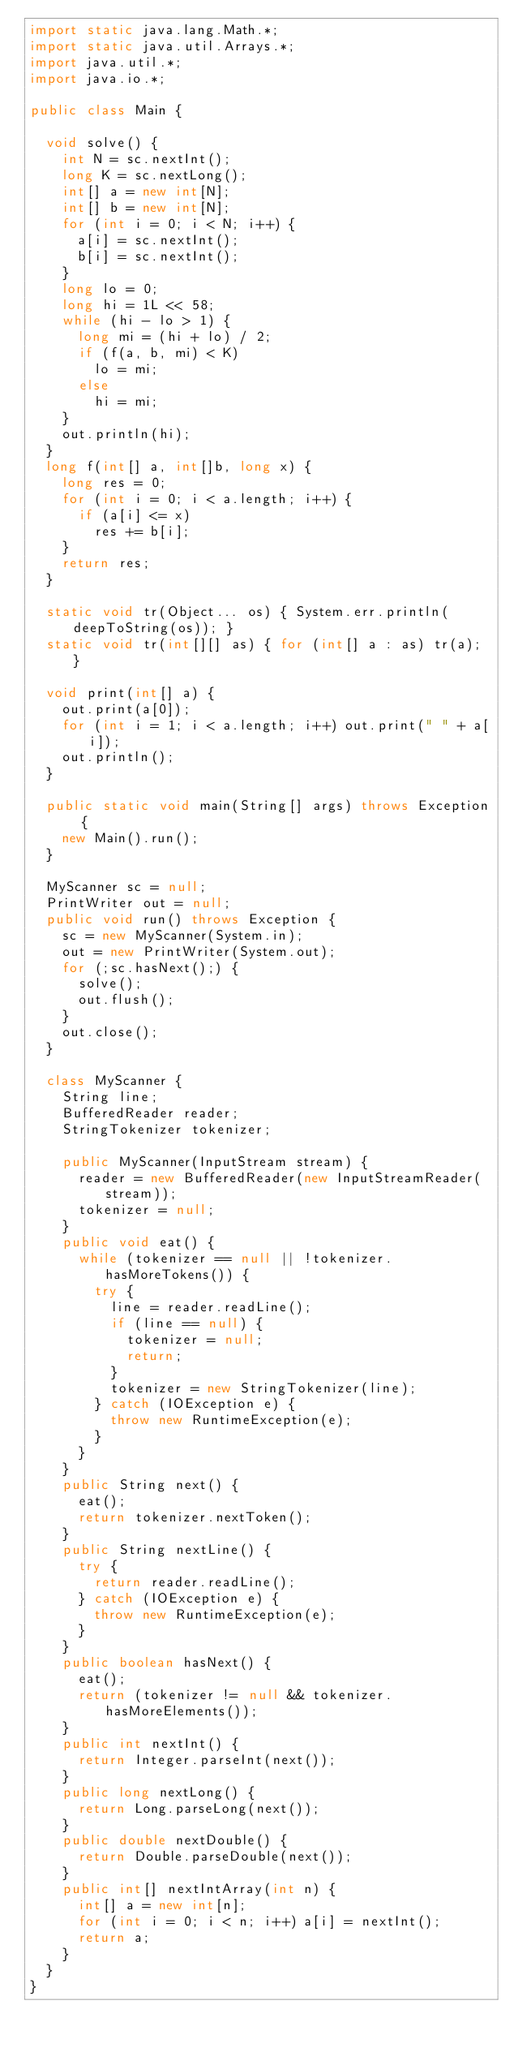<code> <loc_0><loc_0><loc_500><loc_500><_Java_>import static java.lang.Math.*;
import static java.util.Arrays.*;
import java.util.*;
import java.io.*;

public class Main {

	void solve() {
		int N = sc.nextInt();
		long K = sc.nextLong();
		int[] a = new int[N];
		int[] b = new int[N];
		for (int i = 0; i < N; i++) {
			a[i] = sc.nextInt();
			b[i] = sc.nextInt();
		}
		long lo = 0;
		long hi = 1L << 58;
		while (hi - lo > 1) {
			long mi = (hi + lo) / 2;
			if (f(a, b, mi) < K)
				lo = mi;
			else
				hi = mi;
		}
		out.println(hi);
	}
	long f(int[] a, int[]b, long x) {
		long res = 0;
		for (int i = 0; i < a.length; i++) {
			if (a[i] <= x) 
				res += b[i];
		}
		return res;
	}
	
	static void tr(Object... os) { System.err.println(deepToString(os)); }
	static void tr(int[][] as) { for (int[] a : as) tr(a); }

	void print(int[] a) {
		out.print(a[0]);
		for (int i = 1; i < a.length; i++) out.print(" " + a[i]);
		out.println();
	}

	public static void main(String[] args) throws Exception {
		new Main().run();
	}

	MyScanner sc = null;
	PrintWriter out = null;
	public void run() throws Exception {
		sc = new MyScanner(System.in);
		out = new PrintWriter(System.out);
		for (;sc.hasNext();) {
			solve();
			out.flush();
		}
		out.close();
	}

	class MyScanner {
		String line;
		BufferedReader reader;
		StringTokenizer tokenizer;

		public MyScanner(InputStream stream) {
			reader = new BufferedReader(new InputStreamReader(stream));
			tokenizer = null;
		}
		public void eat() {
			while (tokenizer == null || !tokenizer.hasMoreTokens()) {
				try {
					line = reader.readLine();
					if (line == null) {
						tokenizer = null;
						return;
					}
					tokenizer = new StringTokenizer(line);
				} catch (IOException e) {
					throw new RuntimeException(e);
				}
			}
		}
		public String next() {
			eat();
			return tokenizer.nextToken();
		}
		public String nextLine() {
			try {
				return reader.readLine();
			} catch (IOException e) {
				throw new RuntimeException(e);
			}
		}
		public boolean hasNext() {
			eat();
			return (tokenizer != null && tokenizer.hasMoreElements());
		}
		public int nextInt() {
			return Integer.parseInt(next());
		}
		public long nextLong() {
			return Long.parseLong(next());
		}
		public double nextDouble() {
			return Double.parseDouble(next());
		}
		public int[] nextIntArray(int n) {
			int[] a = new int[n];
			for (int i = 0; i < n; i++) a[i] = nextInt();
			return a;
		}
	}
}</code> 